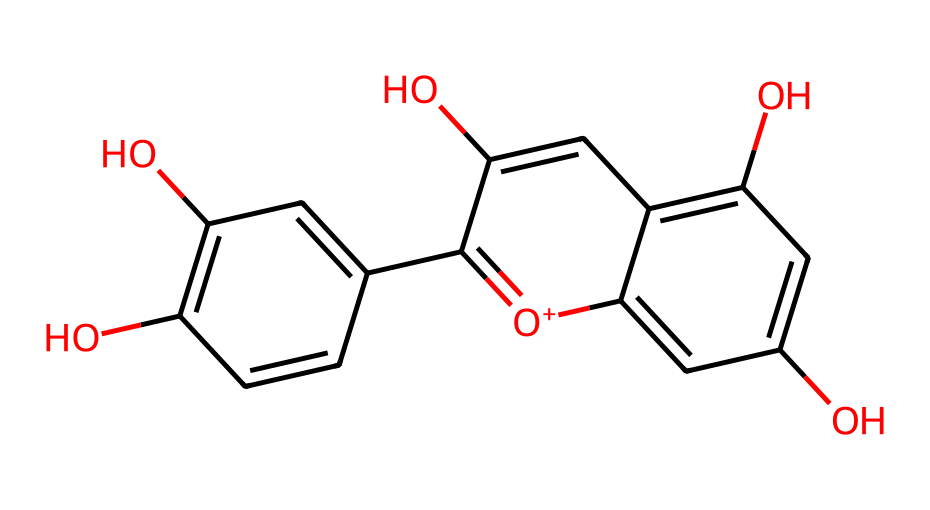What is the molecular formula of this compound? To determine the molecular formula, count the number of each type of atom in the SMILES representation: there are 15 carbons (C), 10 hydrogens (H), and 5 oxygens (O). This gives the molecular formula C15H10O5.
Answer: C15H10O5 How many rings are present in the structure? The chemical structure can be analyzed for rings; there are two fused aromatic rings visible in the SMILES, indicating a total of two rings in the structure.
Answer: 2 What type of chemical compound is represented by this structure? The structure is characteristic of anthocyanins, which are polyphenolic compounds known for their pigmentation in fruits and flowers, particularly berries.
Answer: anthocyanin What functional groups are present in this structure? Looking at the chemical, there are hydroxyl groups (-OH) and a phenolic structure, indicating the presence of multiple hydroxyl functional groups contributing to its properties.
Answer: hydroxyl groups How does this chemical contribute to antioxidant activity? The presence of multiple hydroxyl groups in this flavonoid structure is significant, as these groups can donate hydrogen atoms to free radicals, neutralizing them and contributing to the compound's antioxidant properties.
Answer: antioxidant What is the primary color associated with this type of anthocyanin? Anthocyanins generally impart a red, purple, or blue color to fruits and flowers based on their pH environment, indicating their role in pigmentation.
Answer: red/purple In how many ways can this chemical structure vary in berries? Anthocyanins can vary based on their glycosylation patterns and the presence of different aglycone forms; at least 6 commonly identified types exist in berries.
Answer: 6 